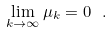Convert formula to latex. <formula><loc_0><loc_0><loc_500><loc_500>\lim _ { k \to \infty } \mu _ { k } = 0 \ .</formula> 